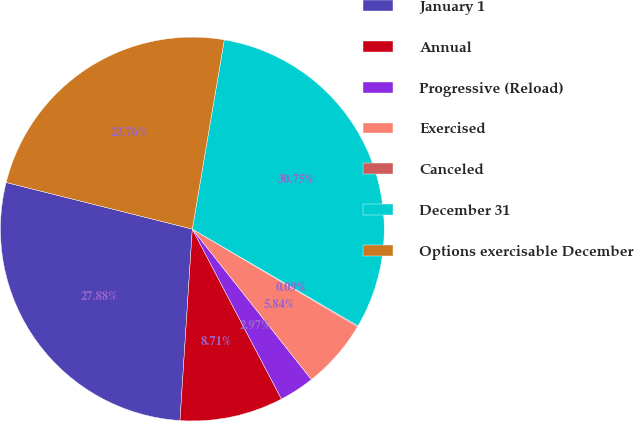<chart> <loc_0><loc_0><loc_500><loc_500><pie_chart><fcel>January 1<fcel>Annual<fcel>Progressive (Reload)<fcel>Exercised<fcel>Canceled<fcel>December 31<fcel>Options exercisable December<nl><fcel>27.88%<fcel>8.71%<fcel>2.97%<fcel>5.84%<fcel>0.09%<fcel>30.75%<fcel>23.76%<nl></chart> 